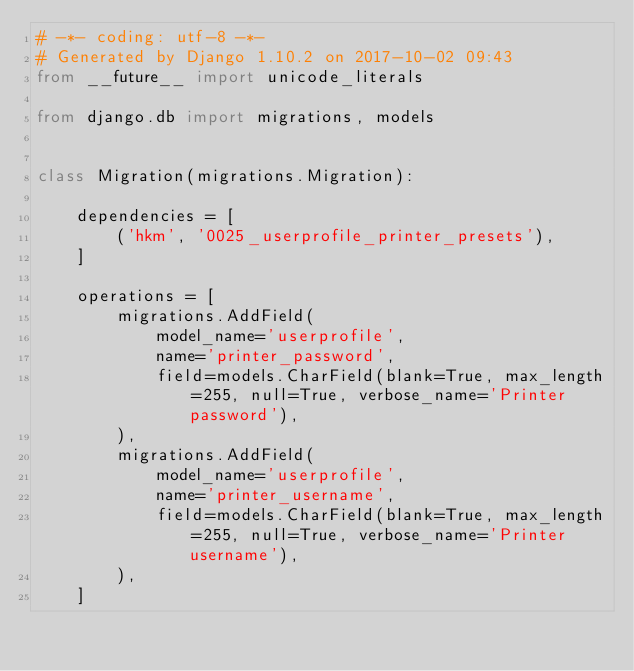<code> <loc_0><loc_0><loc_500><loc_500><_Python_># -*- coding: utf-8 -*-
# Generated by Django 1.10.2 on 2017-10-02 09:43
from __future__ import unicode_literals

from django.db import migrations, models


class Migration(migrations.Migration):

    dependencies = [
        ('hkm', '0025_userprofile_printer_presets'),
    ]

    operations = [
        migrations.AddField(
            model_name='userprofile',
            name='printer_password',
            field=models.CharField(blank=True, max_length=255, null=True, verbose_name='Printer password'),
        ),
        migrations.AddField(
            model_name='userprofile',
            name='printer_username',
            field=models.CharField(blank=True, max_length=255, null=True, verbose_name='Printer username'),
        ),
    ]
</code> 